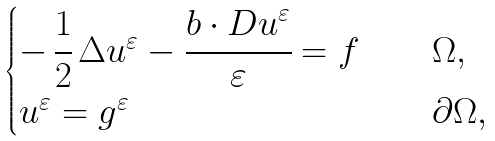Convert formula to latex. <formula><loc_0><loc_0><loc_500><loc_500>\begin{cases} - \, \cfrac { 1 } { 2 } \, \Delta u ^ { \varepsilon } - \cfrac { b \cdot D u ^ { \varepsilon } } { \varepsilon } = f \quad & \Omega , \\ u ^ { \varepsilon } = g ^ { \varepsilon } \quad & \partial \Omega , \end{cases}</formula> 